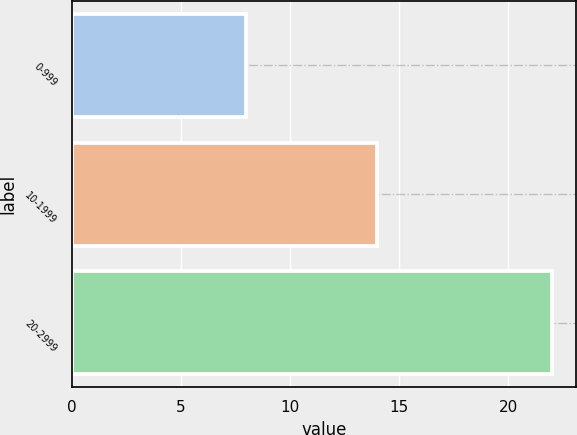Convert chart to OTSL. <chart><loc_0><loc_0><loc_500><loc_500><bar_chart><fcel>0-999<fcel>10-1999<fcel>20-2999<nl><fcel>8<fcel>14<fcel>22<nl></chart> 